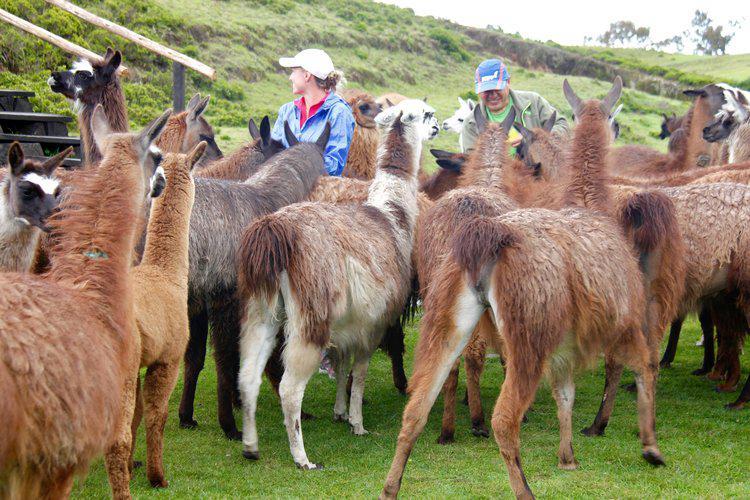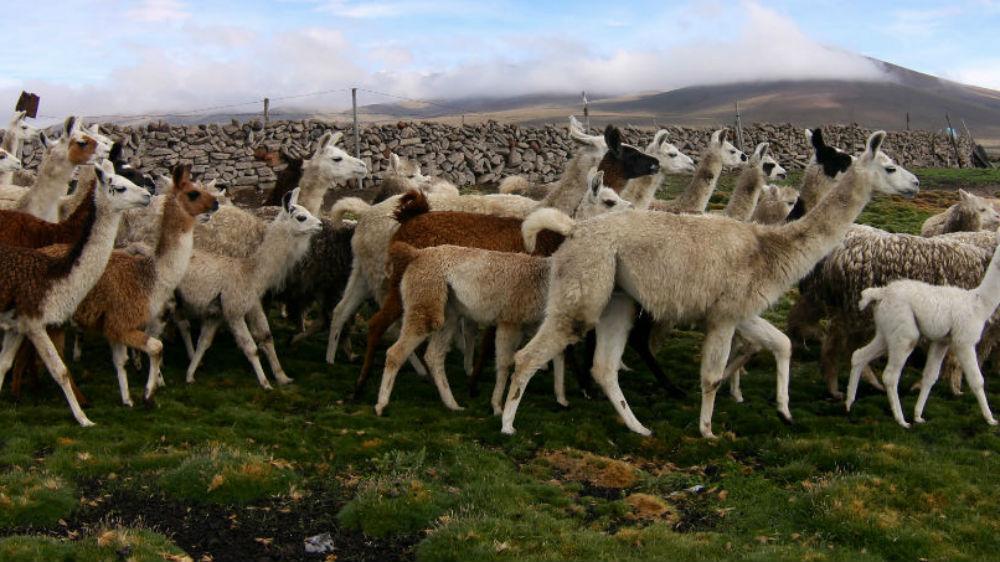The first image is the image on the left, the second image is the image on the right. Given the left and right images, does the statement "Each image includes at least four llamas, and no image shows a group of forward-facing llamas." hold true? Answer yes or no. Yes. The first image is the image on the left, the second image is the image on the right. Given the left and right images, does the statement "In the image to the right, there are fewer than ten llamas." hold true? Answer yes or no. No. 